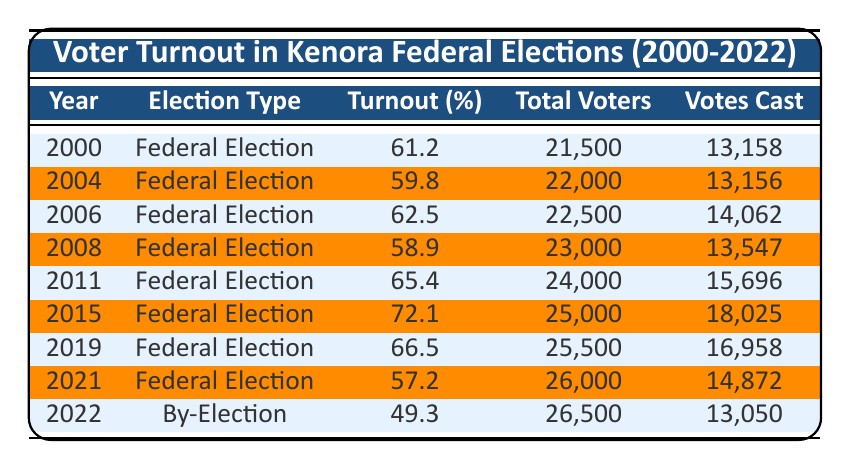What was the voter turnout percentage in Kenora for the federal election in 2015? According to the table, the voter turnout percentage for the federal election in 2015 is listed directly as 72.1%.
Answer: 72.1% How many votes were cast in the federal election of 2021? The table indicates that the total votes cast in the federal election of 2021 is 14,872.
Answer: 14,872 What was the average voter turnout percentage for federal elections from 2000 to 2022? To find the average, we sum the percentages for federal elections from 2000 to 2021 (61.2 + 59.8 + 62.5 + 58.9 + 65.4 + 72.1 + 66.5 + 57.2) = 463.6, then divide by the number of elections (8), giving us 463.6 / 8 = 57.95%.
Answer: 57.95% Was the voter turnout higher in 2015 compared to 2019? By comparing the turnout percentages, 2015 had a voter turnout of 72.1% while 2019 had 66.5%. Since 72.1% is greater than 66.5%, the statement is true.
Answer: Yes What is the difference in voter turnout percentage between the federal election in 2000 and the by-election in 2022? The voter turnout in 2000 was 61.2%, and in 2022 it was 49.3%. The difference is calculated as 61.2 - 49.3 = 11.9.
Answer: 11.9 In which year was the lowest voter turnout for a federal election recorded? By examining the table, the federal election with the lowest turnout was in 2021, with a percentage of 57.2%, which is lower than all other federal election years listed.
Answer: 2021 What percentage of total voters actually voted in the federal election of 2004? The total votes cast in 2004 are 13,156 and the total voters are 22,000. To find the percentage, calculate (13,156 / 22,000) * 100 = 59.8%, which matches the reported turnout percentage.
Answer: 59.8% Was the voter turnout higher in 2019 than in 2021? The voter turnout percentage for 2019 is 66.5%, whereas for 2021 it is 57.2%. Since 66.5% is greater than 57.2%, this statement is true.
Answer: Yes 